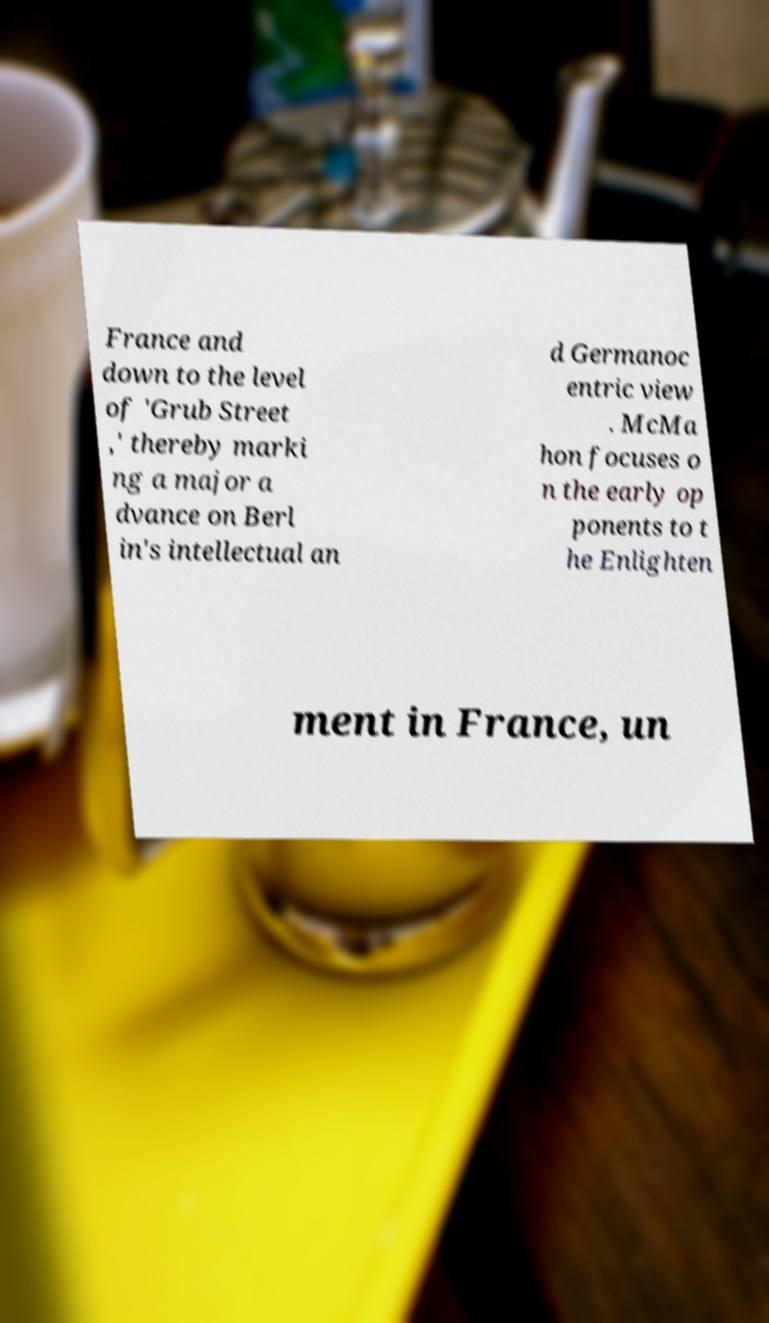Please identify and transcribe the text found in this image. France and down to the level of 'Grub Street ,' thereby marki ng a major a dvance on Berl in's intellectual an d Germanoc entric view . McMa hon focuses o n the early op ponents to t he Enlighten ment in France, un 